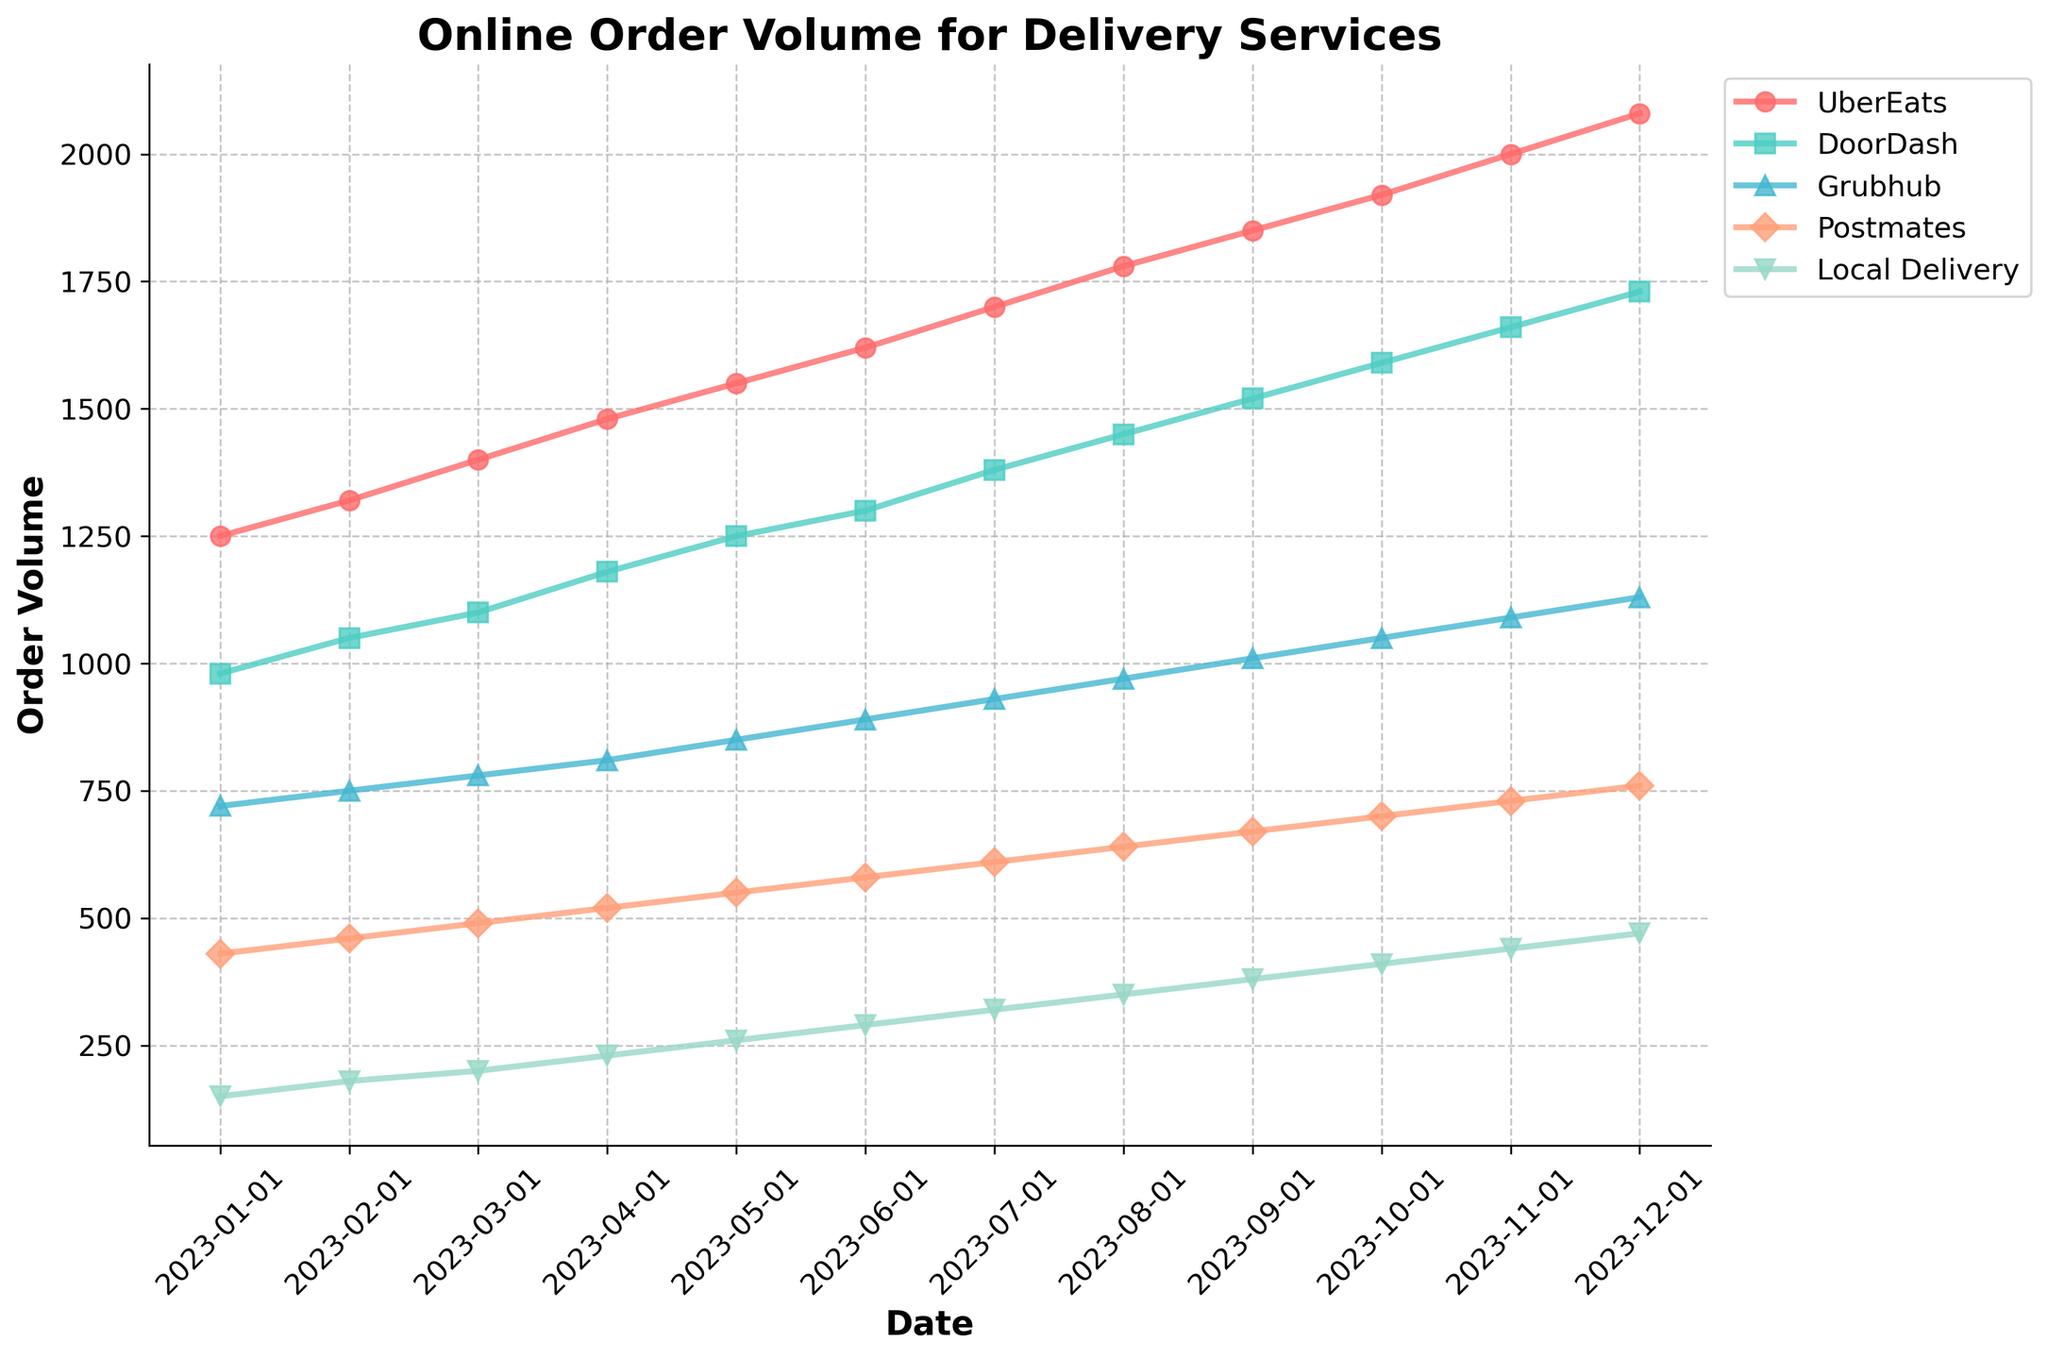what's the average order volume of UberEats in 2023? Sum the order volumes of UberEats from January to December (1250 + 1320 + 1400 + 1480 + 1550 + 1620 + 1700 + 1780 + 1850 + 1920 + 2000 + 2080 = 19950). Divide by 12 (months) to get the average. 19950 / 12 = 1662.5
Answer: 1662.5 which delivery service had the highest order volume in December 2023? The figure shows order volumes for each delivery service in December 2023. UberEats has the highest order volume of 2080 compared to others.
Answer: UberEats by how much did the order volume of DoorDash change from January to December 2023? Subtract the order volume of DoorDash in January (980) from the order volume in December (1730). 1730 - 980 = 750
Answer: 750 what's the total order volume of Grubhub throughout 2023? Sum the order volumes of Grubhub from January to December (720 + 750 + 780 + 810 + 850 + 890 + 930 + 970 + 1010 + 1050 + 1090 + 1130 = 10980)
Answer: 10980 which month showed the highest increase in UberEats order volume compared to the previous month? Calculate the difference in UberEats order volume between each consecutive month and identify the highest increase: Jan to Feb (1320-1250 = 70), Feb to Mar (1400-1320 = 80), Mar to Apr (1480-1400 = 80), Apr to May (1550-1480 = 70), May to Jun (1620-1550 = 70), Jun to Jul (1700-1620 = 80), Jul to Aug (1780-1700 = 80), Aug to Sep (1850-1780 = 70), Sep to Oct (1920-1850 = 70), Oct to Nov (2000-1920 = 80), Nov to Dec (2080-2000 = 80). March, July, August, October, and November show the highest increases of 80.
Answer: March, July, August, October, November which delivery service had the smallest order volume in March 2023? Look at the figure for March 2023 and compare the order volumes of the services. Local Delivery has the smallest order volume of 200.
Answer: Local Delivery whose order volume was higher in July 2023, Grubhub or Postmates? Look at the order volumes for Grubhub (930) and Postmates (610) in July 2023. Grubhub has a higher order volume.
Answer: Grubhub what is the average order volume of Local Delivery for the first half of 2023? Sum the order volumes of Local Delivery from January to June (150 + 180 + 200 + 230 + 260 + 290 = 1310). Divide by 6 (months) to get the average. 1310 / 6 = 218.3
Answer: 218.3 